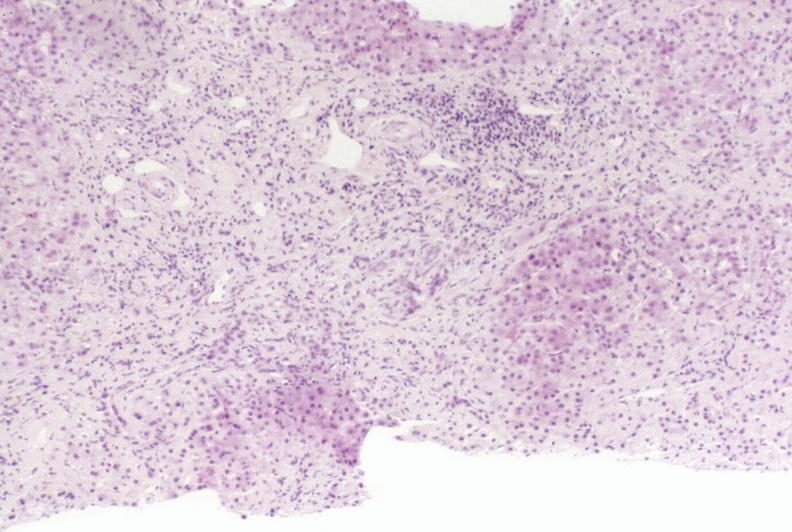what is present?
Answer the question using a single word or phrase. Hepatobiliary 